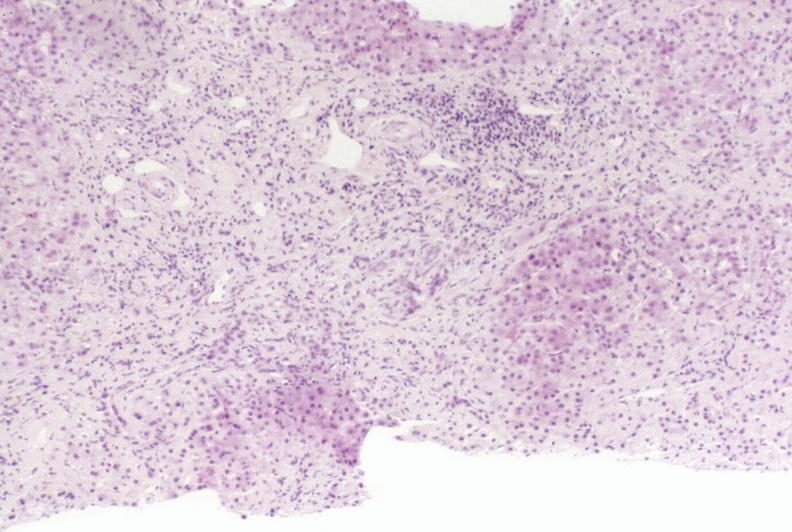what is present?
Answer the question using a single word or phrase. Hepatobiliary 